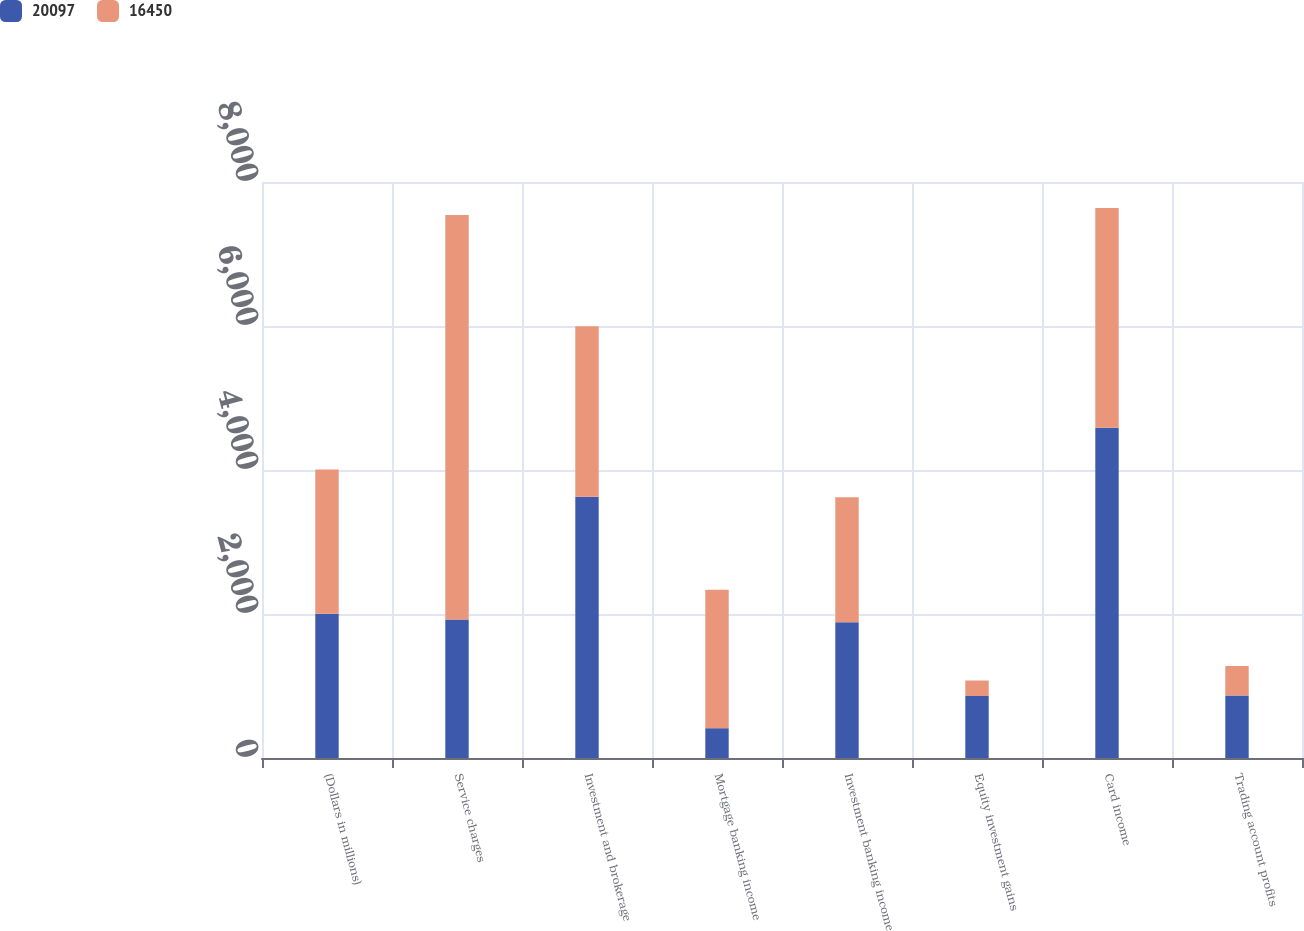Convert chart. <chart><loc_0><loc_0><loc_500><loc_500><stacked_bar_chart><ecel><fcel>(Dollars in millions)<fcel>Service charges<fcel>Investment and brokerage<fcel>Mortgage banking income<fcel>Investment banking income<fcel>Equity investment gains<fcel>Card income<fcel>Trading account profits<nl><fcel>20097<fcel>2004<fcel>1922<fcel>3627<fcel>414<fcel>1886<fcel>861<fcel>4588<fcel>869<nl><fcel>16450<fcel>2003<fcel>5618<fcel>2371<fcel>1922<fcel>1736<fcel>215<fcel>3052<fcel>409<nl></chart> 